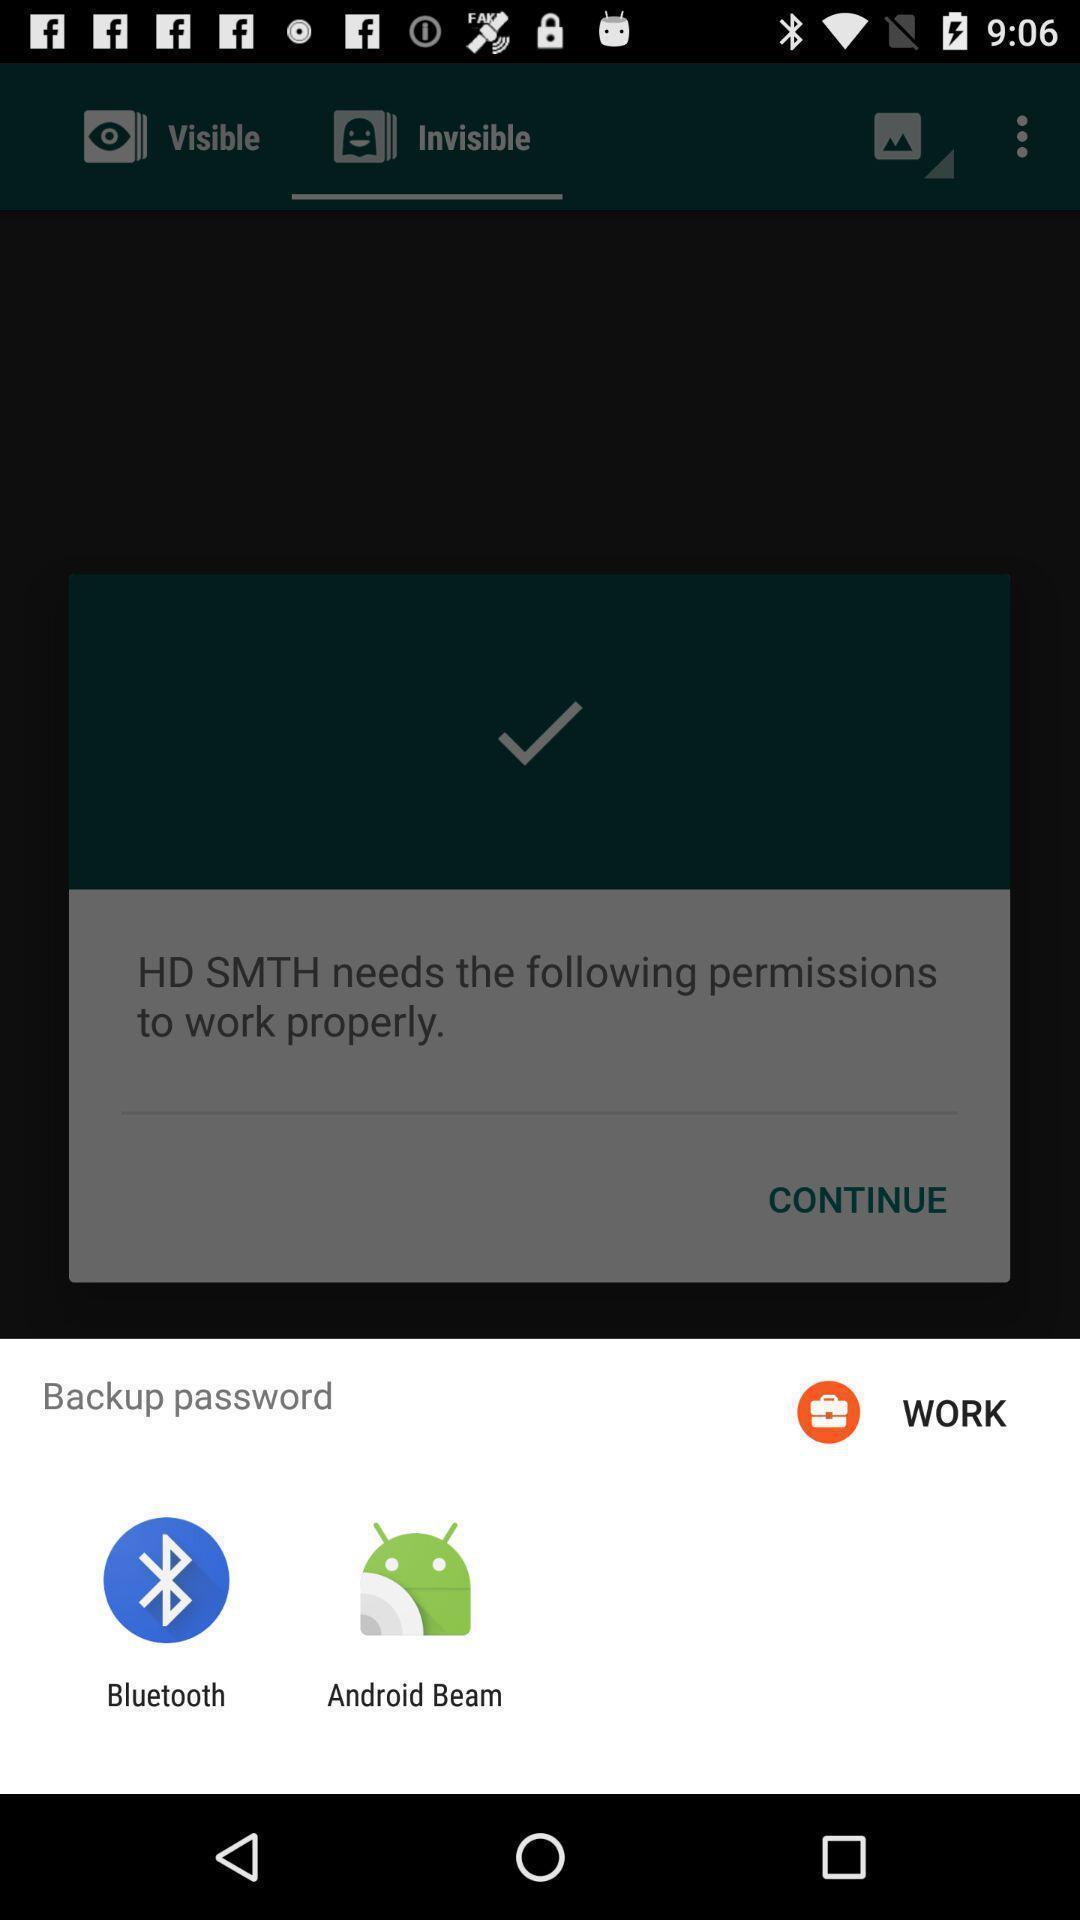Summarize the information in this screenshot. Popup to backup in the gallery app. 